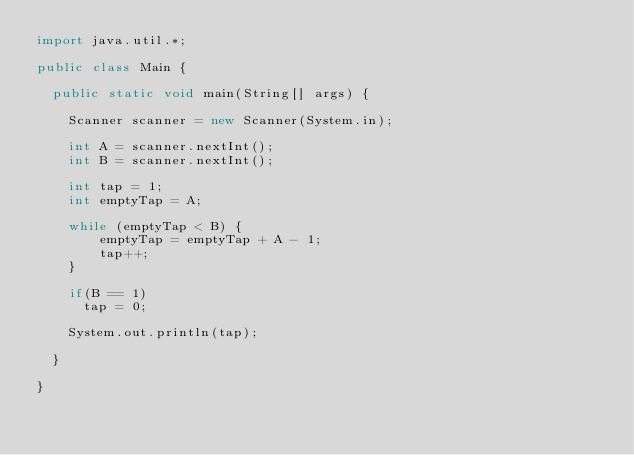<code> <loc_0><loc_0><loc_500><loc_500><_Java_>import java.util.*;

public class Main {

	public static void main(String[] args) {

		Scanner scanner = new Scanner(System.in);

		int A = scanner.nextInt();
		int B = scanner.nextInt();

		int tap = 1;
		int emptyTap = A;

		while (emptyTap < B) {
				emptyTap = emptyTap + A - 1;
				tap++;
		}
		
		if(B == 1)
			tap = 0;

		System.out.println(tap);

	}

}
</code> 